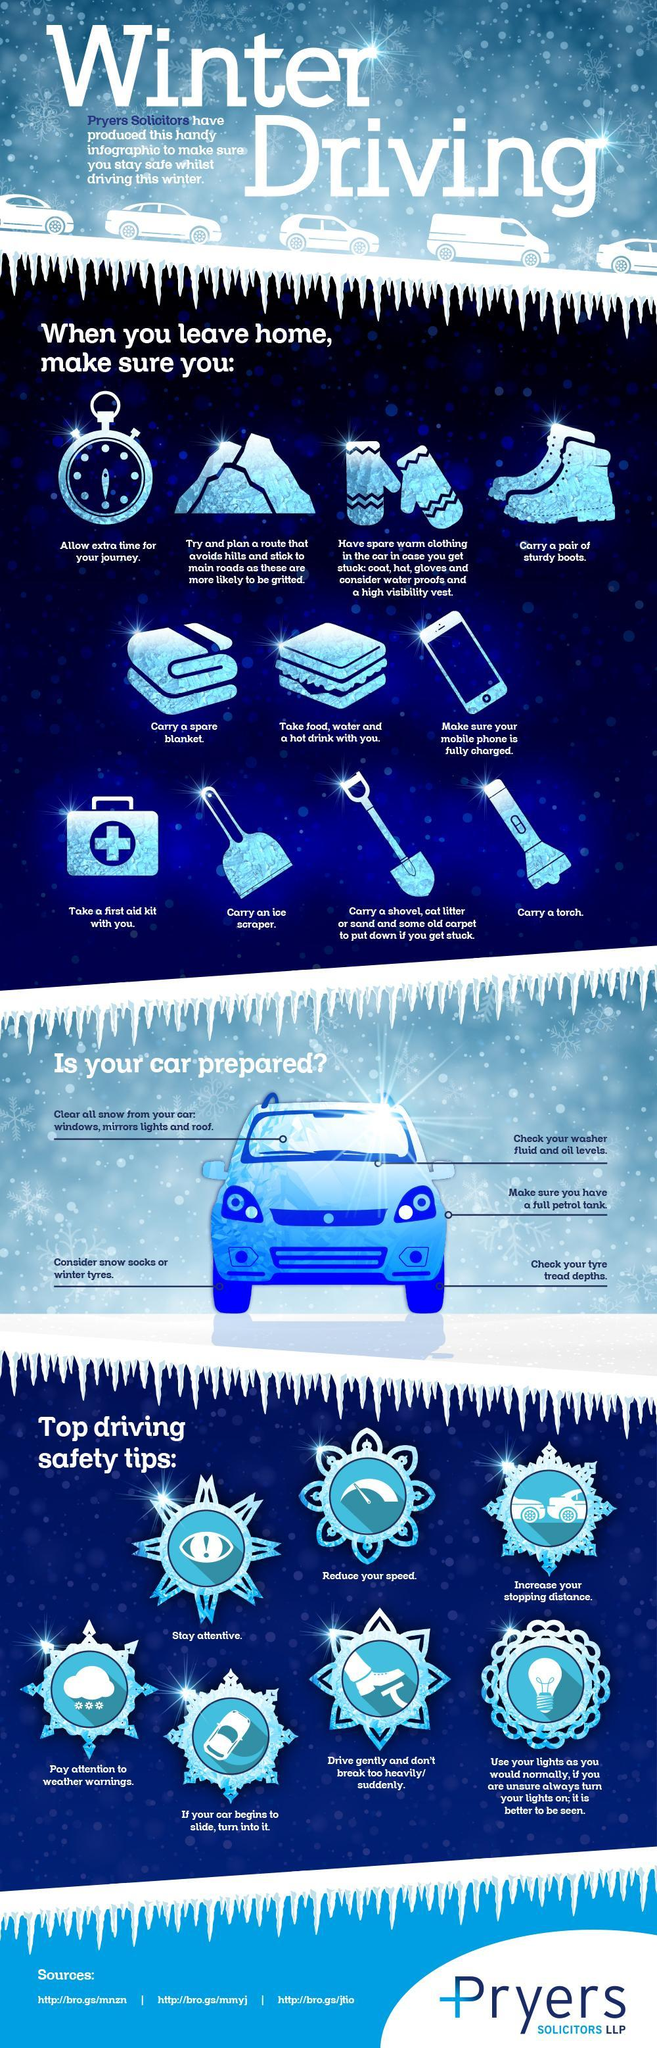In leaving home tips, what does the clock indicate
Answer the question with a short phrase. allow extra time for your journey In leaving home tips, what does the mobile indicate Make sure your mobile phone is fully charged how many safety tips have been mentioned 7 which climate is being discussed winter In the safety tip, what does the exclamation mark define stay attentive how many points to be taken care of for ensuring your car is prepared 5 